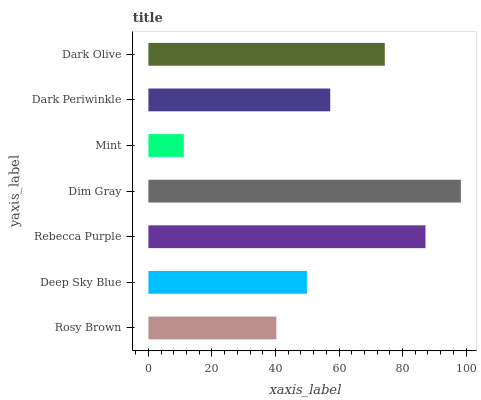Is Mint the minimum?
Answer yes or no. Yes. Is Dim Gray the maximum?
Answer yes or no. Yes. Is Deep Sky Blue the minimum?
Answer yes or no. No. Is Deep Sky Blue the maximum?
Answer yes or no. No. Is Deep Sky Blue greater than Rosy Brown?
Answer yes or no. Yes. Is Rosy Brown less than Deep Sky Blue?
Answer yes or no. Yes. Is Rosy Brown greater than Deep Sky Blue?
Answer yes or no. No. Is Deep Sky Blue less than Rosy Brown?
Answer yes or no. No. Is Dark Periwinkle the high median?
Answer yes or no. Yes. Is Dark Periwinkle the low median?
Answer yes or no. Yes. Is Deep Sky Blue the high median?
Answer yes or no. No. Is Dark Olive the low median?
Answer yes or no. No. 